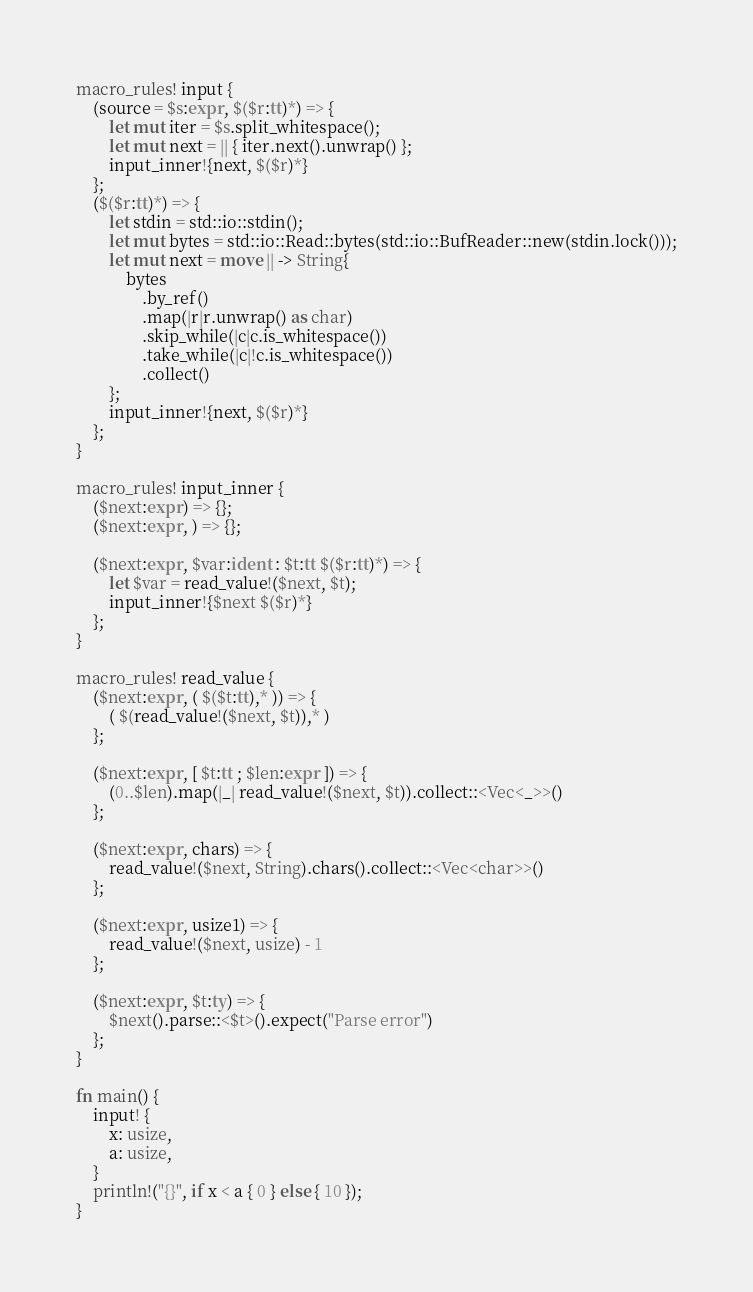<code> <loc_0><loc_0><loc_500><loc_500><_Rust_>macro_rules! input {
    (source = $s:expr, $($r:tt)*) => {
        let mut iter = $s.split_whitespace();
        let mut next = || { iter.next().unwrap() };
        input_inner!{next, $($r)*}
    };
    ($($r:tt)*) => {
        let stdin = std::io::stdin();
        let mut bytes = std::io::Read::bytes(std::io::BufReader::new(stdin.lock()));
        let mut next = move || -> String{
            bytes
                .by_ref()
                .map(|r|r.unwrap() as char)
                .skip_while(|c|c.is_whitespace())
                .take_while(|c|!c.is_whitespace())
                .collect()
        };
        input_inner!{next, $($r)*}
    };
}

macro_rules! input_inner {
    ($next:expr) => {};
    ($next:expr, ) => {};

    ($next:expr, $var:ident : $t:tt $($r:tt)*) => {
        let $var = read_value!($next, $t);
        input_inner!{$next $($r)*}
    };
}

macro_rules! read_value {
    ($next:expr, ( $($t:tt),* )) => {
        ( $(read_value!($next, $t)),* )
    };

    ($next:expr, [ $t:tt ; $len:expr ]) => {
        (0..$len).map(|_| read_value!($next, $t)).collect::<Vec<_>>()
    };

    ($next:expr, chars) => {
        read_value!($next, String).chars().collect::<Vec<char>>()
    };

    ($next:expr, usize1) => {
        read_value!($next, usize) - 1
    };

    ($next:expr, $t:ty) => {
        $next().parse::<$t>().expect("Parse error")
    };
}

fn main() {
    input! {
        x: usize,
        a: usize,
    }
    println!("{}", if x < a { 0 } else { 10 });
}
</code> 